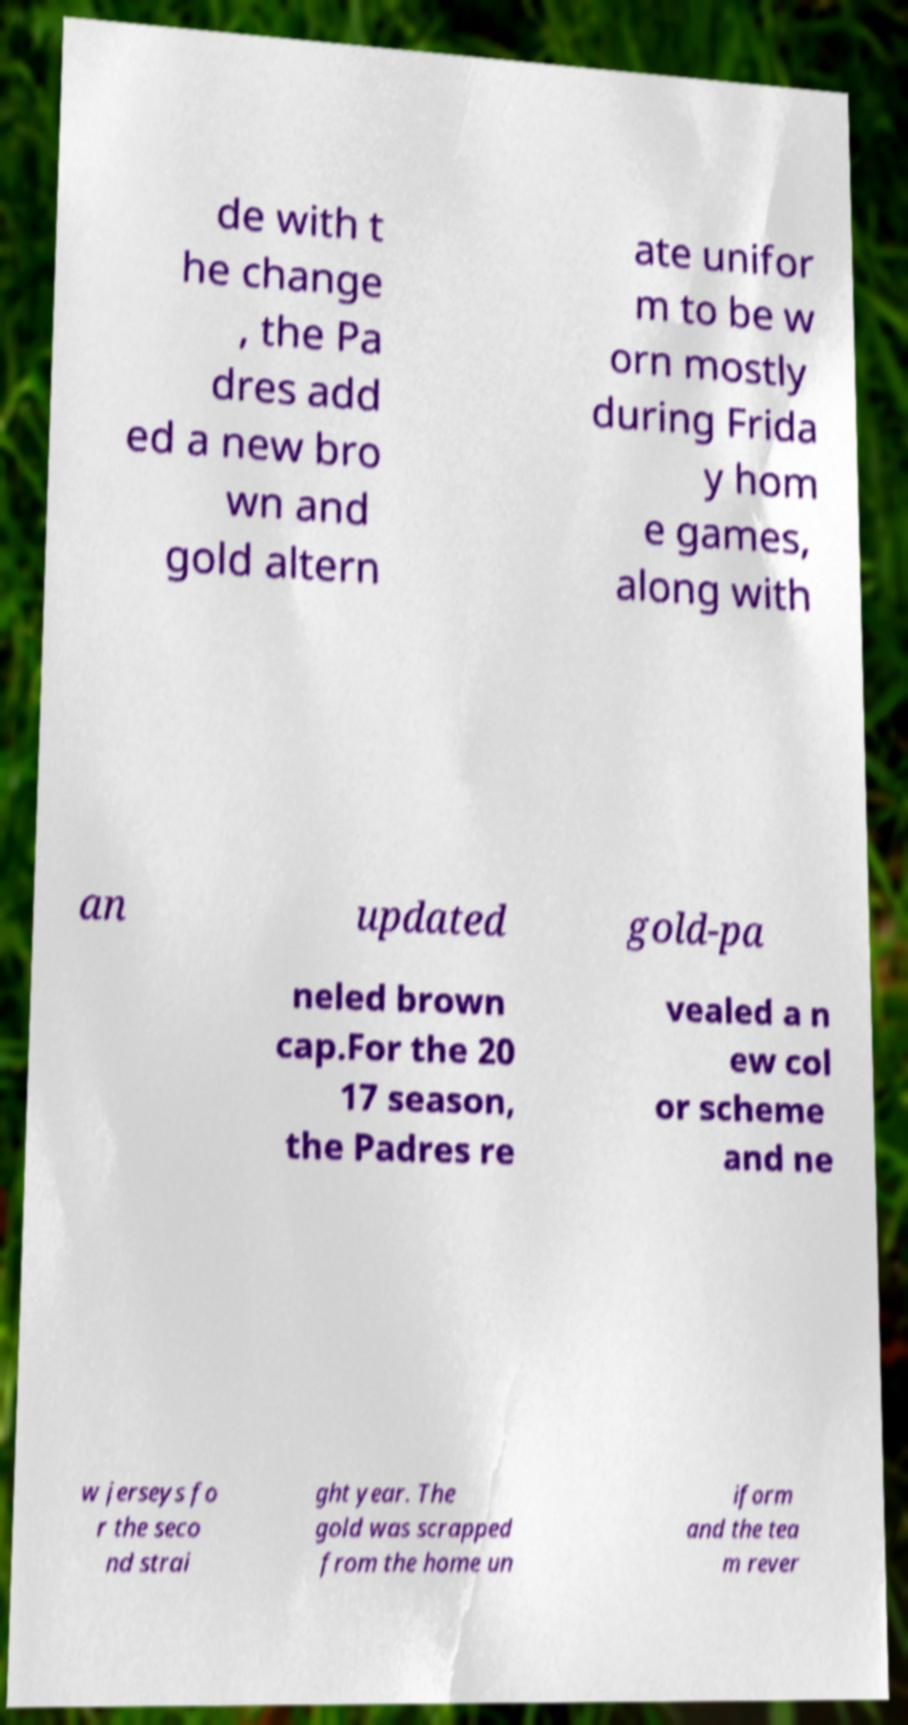Could you extract and type out the text from this image? de with t he change , the Pa dres add ed a new bro wn and gold altern ate unifor m to be w orn mostly during Frida y hom e games, along with an updated gold-pa neled brown cap.For the 20 17 season, the Padres re vealed a n ew col or scheme and ne w jerseys fo r the seco nd strai ght year. The gold was scrapped from the home un iform and the tea m rever 